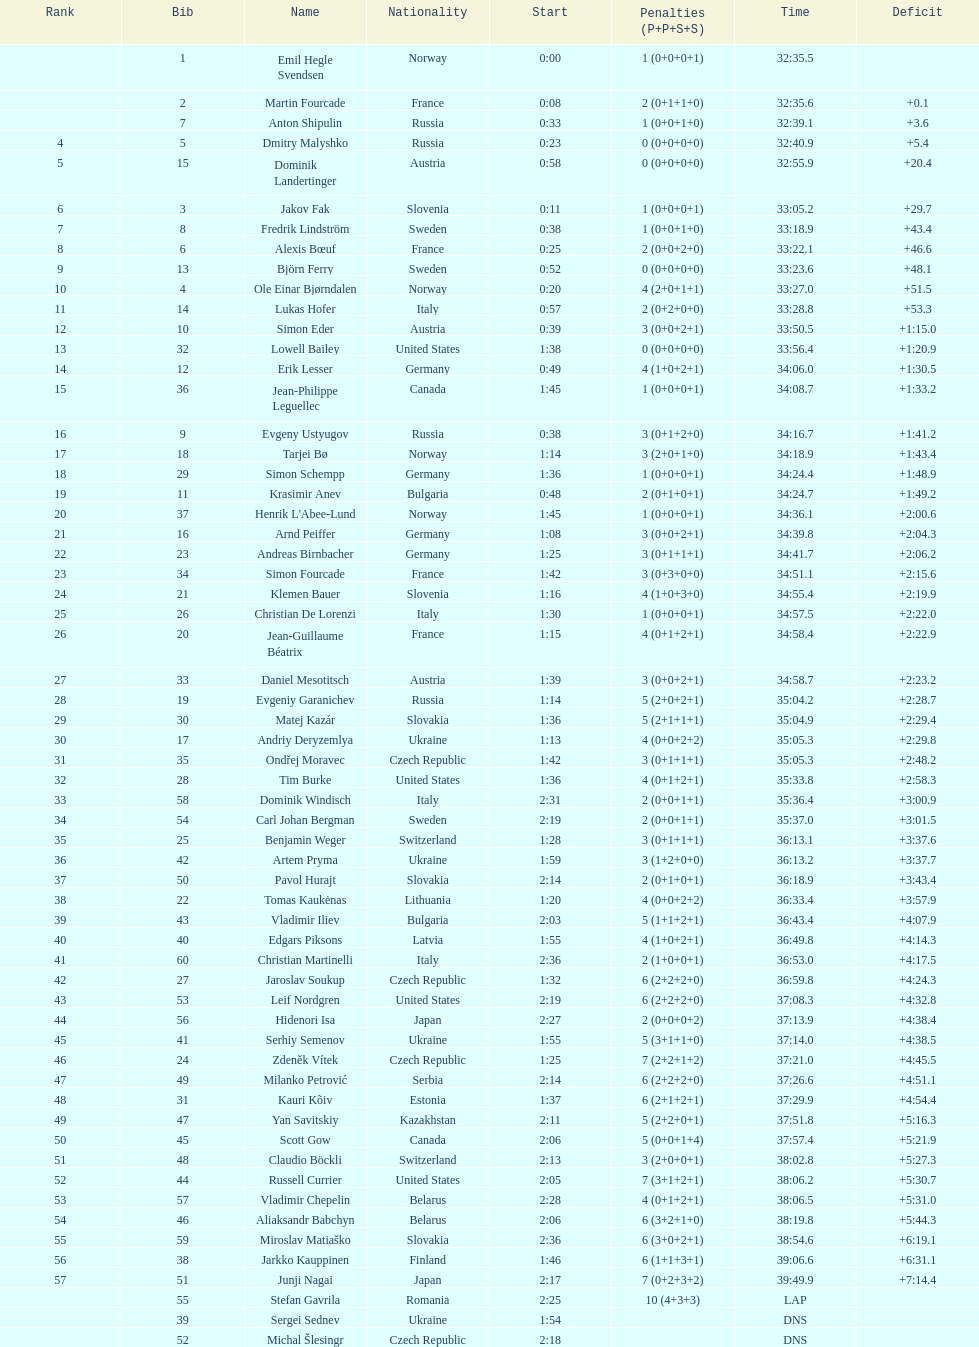Who holds the highest ranking among swedish runners? Fredrik Lindström. 